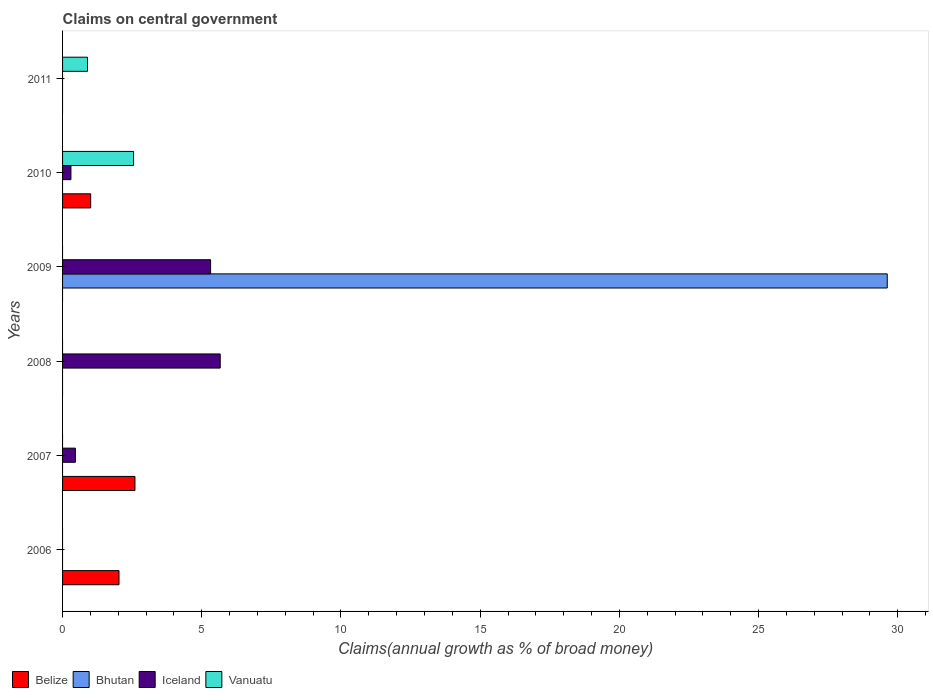Across all years, what is the maximum percentage of broad money claimed on centeral government in Iceland?
Offer a very short reply. 5.66. Across all years, what is the minimum percentage of broad money claimed on centeral government in Belize?
Provide a succinct answer. 0. What is the total percentage of broad money claimed on centeral government in Belize in the graph?
Your answer should be compact. 5.64. What is the difference between the percentage of broad money claimed on centeral government in Iceland in 2007 and that in 2008?
Offer a very short reply. -5.2. What is the difference between the percentage of broad money claimed on centeral government in Vanuatu in 2010 and the percentage of broad money claimed on centeral government in Bhutan in 2006?
Give a very brief answer. 2.55. What is the average percentage of broad money claimed on centeral government in Belize per year?
Your answer should be very brief. 0.94. What is the ratio of the percentage of broad money claimed on centeral government in Vanuatu in 2010 to that in 2011?
Your response must be concise. 2.84. What is the difference between the highest and the second highest percentage of broad money claimed on centeral government in Iceland?
Keep it short and to the point. 0.35. What is the difference between the highest and the lowest percentage of broad money claimed on centeral government in Belize?
Your answer should be compact. 2.6. Is the sum of the percentage of broad money claimed on centeral government in Iceland in 2007 and 2009 greater than the maximum percentage of broad money claimed on centeral government in Vanuatu across all years?
Your answer should be compact. Yes. Is it the case that in every year, the sum of the percentage of broad money claimed on centeral government in Vanuatu and percentage of broad money claimed on centeral government in Bhutan is greater than the sum of percentage of broad money claimed on centeral government in Iceland and percentage of broad money claimed on centeral government in Belize?
Offer a very short reply. No. Is it the case that in every year, the sum of the percentage of broad money claimed on centeral government in Bhutan and percentage of broad money claimed on centeral government in Iceland is greater than the percentage of broad money claimed on centeral government in Belize?
Ensure brevity in your answer.  No. How many bars are there?
Ensure brevity in your answer.  10. Are the values on the major ticks of X-axis written in scientific E-notation?
Your answer should be compact. No. Where does the legend appear in the graph?
Ensure brevity in your answer.  Bottom left. How many legend labels are there?
Make the answer very short. 4. What is the title of the graph?
Give a very brief answer. Claims on central government. What is the label or title of the X-axis?
Give a very brief answer. Claims(annual growth as % of broad money). What is the label or title of the Y-axis?
Offer a very short reply. Years. What is the Claims(annual growth as % of broad money) in Belize in 2006?
Your response must be concise. 2.03. What is the Claims(annual growth as % of broad money) of Vanuatu in 2006?
Your response must be concise. 0. What is the Claims(annual growth as % of broad money) of Belize in 2007?
Your answer should be very brief. 2.6. What is the Claims(annual growth as % of broad money) in Iceland in 2007?
Your answer should be compact. 0.46. What is the Claims(annual growth as % of broad money) of Vanuatu in 2007?
Offer a terse response. 0. What is the Claims(annual growth as % of broad money) of Belize in 2008?
Provide a short and direct response. 0. What is the Claims(annual growth as % of broad money) in Bhutan in 2008?
Make the answer very short. 0. What is the Claims(annual growth as % of broad money) in Iceland in 2008?
Keep it short and to the point. 5.66. What is the Claims(annual growth as % of broad money) in Bhutan in 2009?
Provide a short and direct response. 29.62. What is the Claims(annual growth as % of broad money) in Iceland in 2009?
Your response must be concise. 5.32. What is the Claims(annual growth as % of broad money) in Belize in 2010?
Provide a short and direct response. 1.01. What is the Claims(annual growth as % of broad money) in Bhutan in 2010?
Ensure brevity in your answer.  0. What is the Claims(annual growth as % of broad money) in Iceland in 2010?
Provide a succinct answer. 0.3. What is the Claims(annual growth as % of broad money) of Vanuatu in 2010?
Offer a very short reply. 2.55. What is the Claims(annual growth as % of broad money) in Bhutan in 2011?
Provide a succinct answer. 0. What is the Claims(annual growth as % of broad money) of Iceland in 2011?
Provide a short and direct response. 0. What is the Claims(annual growth as % of broad money) of Vanuatu in 2011?
Ensure brevity in your answer.  0.9. Across all years, what is the maximum Claims(annual growth as % of broad money) in Belize?
Ensure brevity in your answer.  2.6. Across all years, what is the maximum Claims(annual growth as % of broad money) in Bhutan?
Ensure brevity in your answer.  29.62. Across all years, what is the maximum Claims(annual growth as % of broad money) of Iceland?
Provide a short and direct response. 5.66. Across all years, what is the maximum Claims(annual growth as % of broad money) of Vanuatu?
Your response must be concise. 2.55. Across all years, what is the minimum Claims(annual growth as % of broad money) of Belize?
Ensure brevity in your answer.  0. What is the total Claims(annual growth as % of broad money) of Belize in the graph?
Keep it short and to the point. 5.64. What is the total Claims(annual growth as % of broad money) in Bhutan in the graph?
Keep it short and to the point. 29.62. What is the total Claims(annual growth as % of broad money) of Iceland in the graph?
Your answer should be compact. 11.74. What is the total Claims(annual growth as % of broad money) in Vanuatu in the graph?
Offer a very short reply. 3.45. What is the difference between the Claims(annual growth as % of broad money) of Belize in 2006 and that in 2007?
Your answer should be very brief. -0.57. What is the difference between the Claims(annual growth as % of broad money) in Belize in 2006 and that in 2010?
Your response must be concise. 1.02. What is the difference between the Claims(annual growth as % of broad money) of Iceland in 2007 and that in 2008?
Make the answer very short. -5.2. What is the difference between the Claims(annual growth as % of broad money) of Iceland in 2007 and that in 2009?
Provide a short and direct response. -4.86. What is the difference between the Claims(annual growth as % of broad money) in Belize in 2007 and that in 2010?
Provide a succinct answer. 1.59. What is the difference between the Claims(annual growth as % of broad money) in Iceland in 2007 and that in 2010?
Ensure brevity in your answer.  0.16. What is the difference between the Claims(annual growth as % of broad money) in Iceland in 2008 and that in 2009?
Make the answer very short. 0.35. What is the difference between the Claims(annual growth as % of broad money) of Iceland in 2008 and that in 2010?
Keep it short and to the point. 5.36. What is the difference between the Claims(annual growth as % of broad money) of Iceland in 2009 and that in 2010?
Your answer should be very brief. 5.02. What is the difference between the Claims(annual growth as % of broad money) of Vanuatu in 2010 and that in 2011?
Your answer should be very brief. 1.65. What is the difference between the Claims(annual growth as % of broad money) of Belize in 2006 and the Claims(annual growth as % of broad money) of Iceland in 2007?
Ensure brevity in your answer.  1.57. What is the difference between the Claims(annual growth as % of broad money) of Belize in 2006 and the Claims(annual growth as % of broad money) of Iceland in 2008?
Offer a very short reply. -3.64. What is the difference between the Claims(annual growth as % of broad money) of Belize in 2006 and the Claims(annual growth as % of broad money) of Bhutan in 2009?
Offer a very short reply. -27.6. What is the difference between the Claims(annual growth as % of broad money) of Belize in 2006 and the Claims(annual growth as % of broad money) of Iceland in 2009?
Provide a succinct answer. -3.29. What is the difference between the Claims(annual growth as % of broad money) in Belize in 2006 and the Claims(annual growth as % of broad money) in Iceland in 2010?
Offer a terse response. 1.73. What is the difference between the Claims(annual growth as % of broad money) of Belize in 2006 and the Claims(annual growth as % of broad money) of Vanuatu in 2010?
Give a very brief answer. -0.52. What is the difference between the Claims(annual growth as % of broad money) of Belize in 2006 and the Claims(annual growth as % of broad money) of Vanuatu in 2011?
Give a very brief answer. 1.13. What is the difference between the Claims(annual growth as % of broad money) of Belize in 2007 and the Claims(annual growth as % of broad money) of Iceland in 2008?
Provide a succinct answer. -3.06. What is the difference between the Claims(annual growth as % of broad money) of Belize in 2007 and the Claims(annual growth as % of broad money) of Bhutan in 2009?
Provide a succinct answer. -27.02. What is the difference between the Claims(annual growth as % of broad money) in Belize in 2007 and the Claims(annual growth as % of broad money) in Iceland in 2009?
Provide a short and direct response. -2.72. What is the difference between the Claims(annual growth as % of broad money) of Belize in 2007 and the Claims(annual growth as % of broad money) of Iceland in 2010?
Make the answer very short. 2.3. What is the difference between the Claims(annual growth as % of broad money) in Belize in 2007 and the Claims(annual growth as % of broad money) in Vanuatu in 2010?
Ensure brevity in your answer.  0.05. What is the difference between the Claims(annual growth as % of broad money) in Iceland in 2007 and the Claims(annual growth as % of broad money) in Vanuatu in 2010?
Your answer should be compact. -2.09. What is the difference between the Claims(annual growth as % of broad money) of Belize in 2007 and the Claims(annual growth as % of broad money) of Vanuatu in 2011?
Your answer should be compact. 1.7. What is the difference between the Claims(annual growth as % of broad money) of Iceland in 2007 and the Claims(annual growth as % of broad money) of Vanuatu in 2011?
Provide a succinct answer. -0.44. What is the difference between the Claims(annual growth as % of broad money) in Iceland in 2008 and the Claims(annual growth as % of broad money) in Vanuatu in 2010?
Your answer should be compact. 3.11. What is the difference between the Claims(annual growth as % of broad money) of Iceland in 2008 and the Claims(annual growth as % of broad money) of Vanuatu in 2011?
Your answer should be very brief. 4.77. What is the difference between the Claims(annual growth as % of broad money) of Bhutan in 2009 and the Claims(annual growth as % of broad money) of Iceland in 2010?
Provide a short and direct response. 29.32. What is the difference between the Claims(annual growth as % of broad money) of Bhutan in 2009 and the Claims(annual growth as % of broad money) of Vanuatu in 2010?
Keep it short and to the point. 27.07. What is the difference between the Claims(annual growth as % of broad money) of Iceland in 2009 and the Claims(annual growth as % of broad money) of Vanuatu in 2010?
Your response must be concise. 2.77. What is the difference between the Claims(annual growth as % of broad money) of Bhutan in 2009 and the Claims(annual growth as % of broad money) of Vanuatu in 2011?
Your response must be concise. 28.73. What is the difference between the Claims(annual growth as % of broad money) in Iceland in 2009 and the Claims(annual growth as % of broad money) in Vanuatu in 2011?
Offer a terse response. 4.42. What is the difference between the Claims(annual growth as % of broad money) in Belize in 2010 and the Claims(annual growth as % of broad money) in Vanuatu in 2011?
Keep it short and to the point. 0.11. What is the difference between the Claims(annual growth as % of broad money) of Iceland in 2010 and the Claims(annual growth as % of broad money) of Vanuatu in 2011?
Make the answer very short. -0.6. What is the average Claims(annual growth as % of broad money) in Belize per year?
Your answer should be very brief. 0.94. What is the average Claims(annual growth as % of broad money) in Bhutan per year?
Your answer should be very brief. 4.94. What is the average Claims(annual growth as % of broad money) of Iceland per year?
Give a very brief answer. 1.96. What is the average Claims(annual growth as % of broad money) of Vanuatu per year?
Provide a short and direct response. 0.57. In the year 2007, what is the difference between the Claims(annual growth as % of broad money) of Belize and Claims(annual growth as % of broad money) of Iceland?
Keep it short and to the point. 2.14. In the year 2009, what is the difference between the Claims(annual growth as % of broad money) of Bhutan and Claims(annual growth as % of broad money) of Iceland?
Your answer should be compact. 24.31. In the year 2010, what is the difference between the Claims(annual growth as % of broad money) in Belize and Claims(annual growth as % of broad money) in Iceland?
Offer a terse response. 0.71. In the year 2010, what is the difference between the Claims(annual growth as % of broad money) in Belize and Claims(annual growth as % of broad money) in Vanuatu?
Ensure brevity in your answer.  -1.54. In the year 2010, what is the difference between the Claims(annual growth as % of broad money) in Iceland and Claims(annual growth as % of broad money) in Vanuatu?
Offer a terse response. -2.25. What is the ratio of the Claims(annual growth as % of broad money) in Belize in 2006 to that in 2007?
Offer a terse response. 0.78. What is the ratio of the Claims(annual growth as % of broad money) of Belize in 2006 to that in 2010?
Offer a very short reply. 2.01. What is the ratio of the Claims(annual growth as % of broad money) of Iceland in 2007 to that in 2008?
Your answer should be compact. 0.08. What is the ratio of the Claims(annual growth as % of broad money) in Iceland in 2007 to that in 2009?
Give a very brief answer. 0.09. What is the ratio of the Claims(annual growth as % of broad money) of Belize in 2007 to that in 2010?
Your answer should be very brief. 2.57. What is the ratio of the Claims(annual growth as % of broad money) of Iceland in 2007 to that in 2010?
Offer a terse response. 1.53. What is the ratio of the Claims(annual growth as % of broad money) of Iceland in 2008 to that in 2009?
Provide a short and direct response. 1.06. What is the ratio of the Claims(annual growth as % of broad money) of Iceland in 2008 to that in 2010?
Ensure brevity in your answer.  18.84. What is the ratio of the Claims(annual growth as % of broad money) of Iceland in 2009 to that in 2010?
Your answer should be very brief. 17.69. What is the ratio of the Claims(annual growth as % of broad money) of Vanuatu in 2010 to that in 2011?
Your answer should be very brief. 2.84. What is the difference between the highest and the second highest Claims(annual growth as % of broad money) in Belize?
Offer a terse response. 0.57. What is the difference between the highest and the second highest Claims(annual growth as % of broad money) of Iceland?
Offer a terse response. 0.35. What is the difference between the highest and the lowest Claims(annual growth as % of broad money) in Belize?
Your answer should be compact. 2.6. What is the difference between the highest and the lowest Claims(annual growth as % of broad money) in Bhutan?
Offer a very short reply. 29.62. What is the difference between the highest and the lowest Claims(annual growth as % of broad money) in Iceland?
Your answer should be very brief. 5.66. What is the difference between the highest and the lowest Claims(annual growth as % of broad money) of Vanuatu?
Make the answer very short. 2.55. 